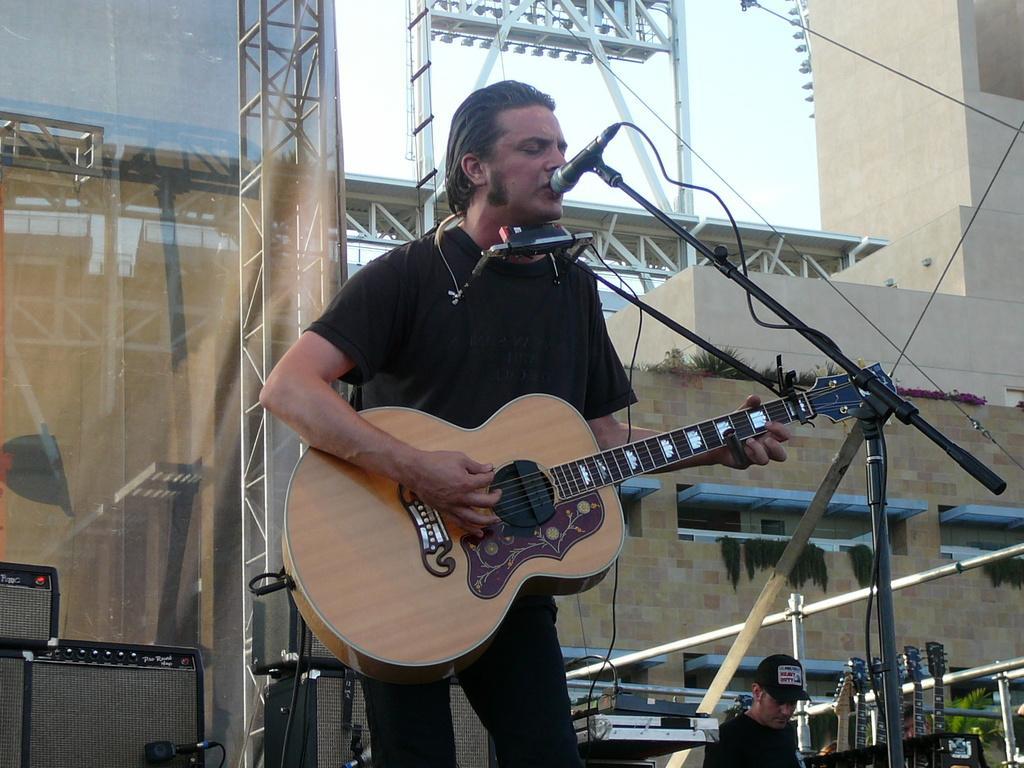In one or two sentences, can you explain what this image depicts? This is a picture of a man in black t shirt holding a guitar and singing a song in front of the man there is a microphone with stand. Behind the man there are music systems and a wall and also a man in black cap was standing. 